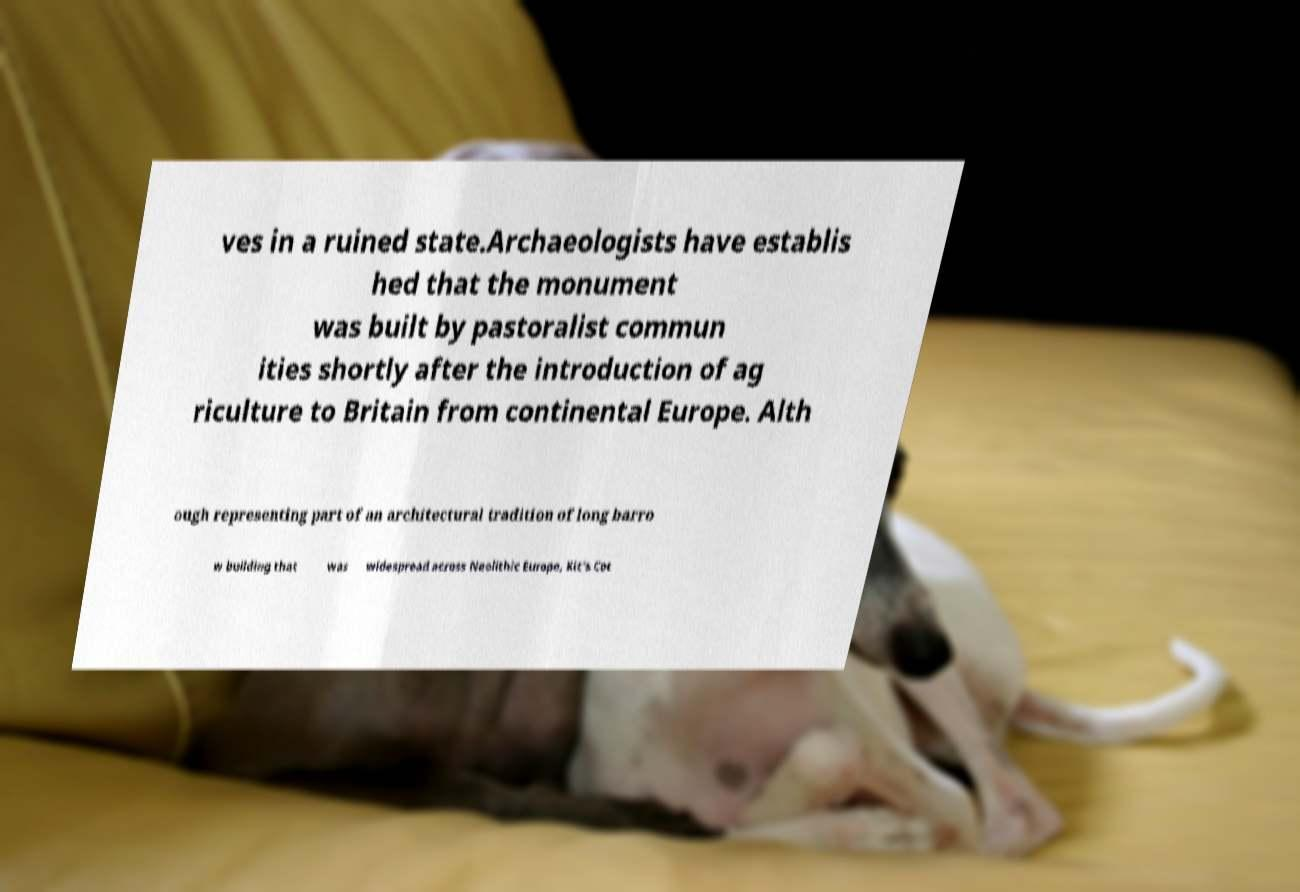For documentation purposes, I need the text within this image transcribed. Could you provide that? ves in a ruined state.Archaeologists have establis hed that the monument was built by pastoralist commun ities shortly after the introduction of ag riculture to Britain from continental Europe. Alth ough representing part of an architectural tradition of long barro w building that was widespread across Neolithic Europe, Kit's Cot 